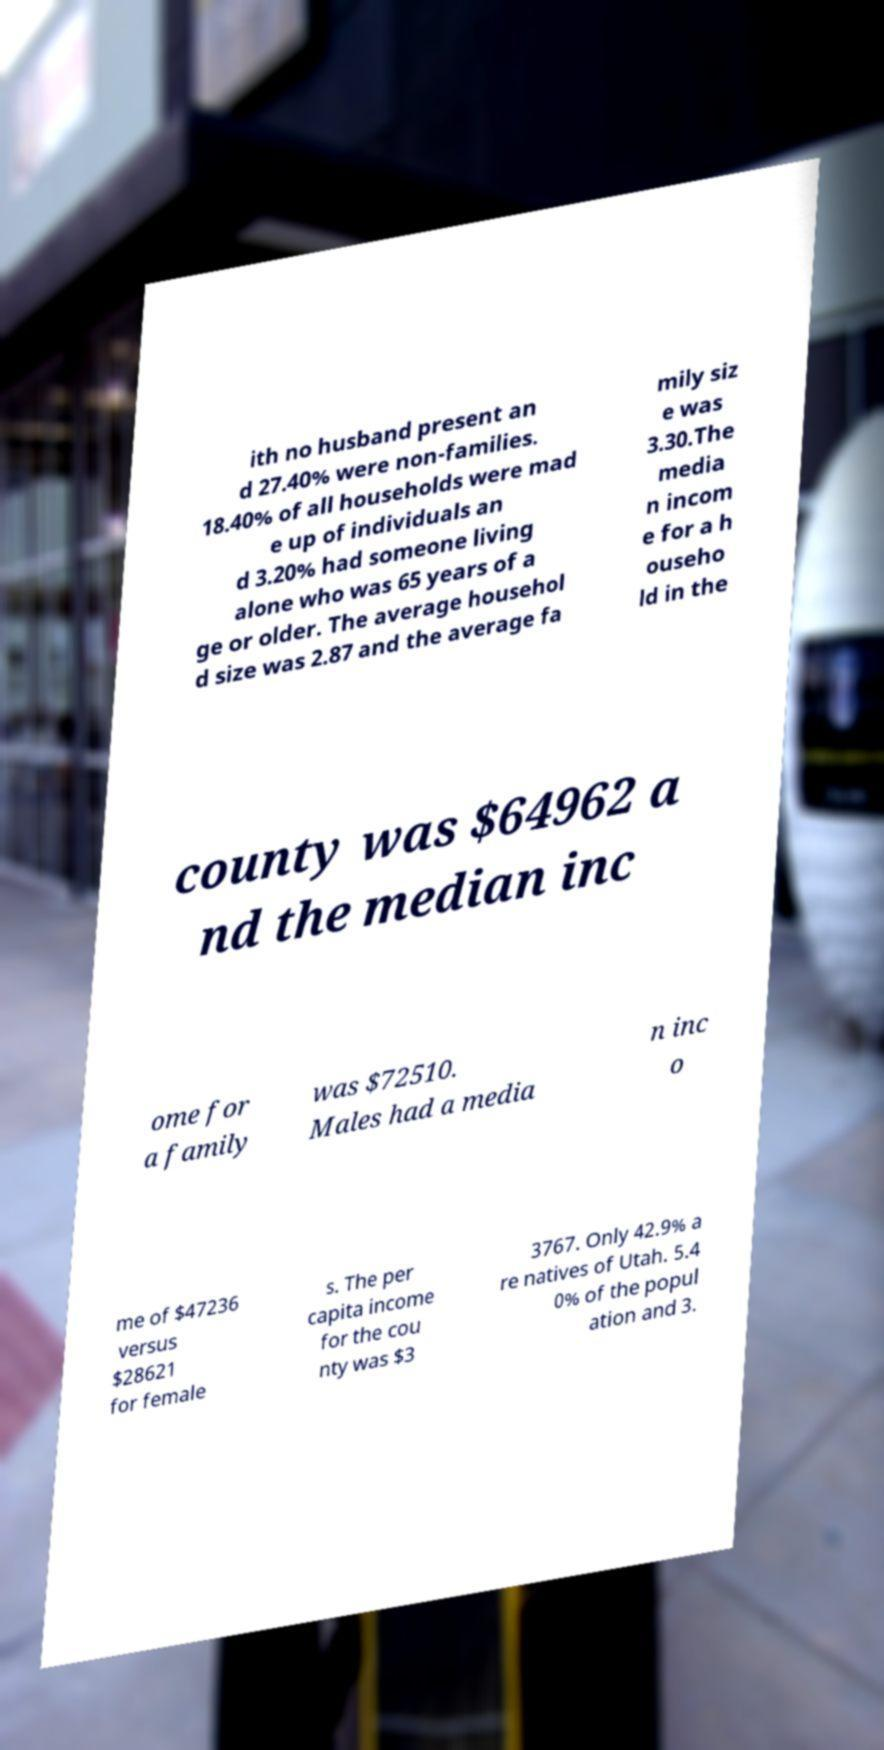Can you accurately transcribe the text from the provided image for me? ith no husband present an d 27.40% were non-families. 18.40% of all households were mad e up of individuals an d 3.20% had someone living alone who was 65 years of a ge or older. The average househol d size was 2.87 and the average fa mily siz e was 3.30.The media n incom e for a h ouseho ld in the county was $64962 a nd the median inc ome for a family was $72510. Males had a media n inc o me of $47236 versus $28621 for female s. The per capita income for the cou nty was $3 3767. Only 42.9% a re natives of Utah. 5.4 0% of the popul ation and 3. 